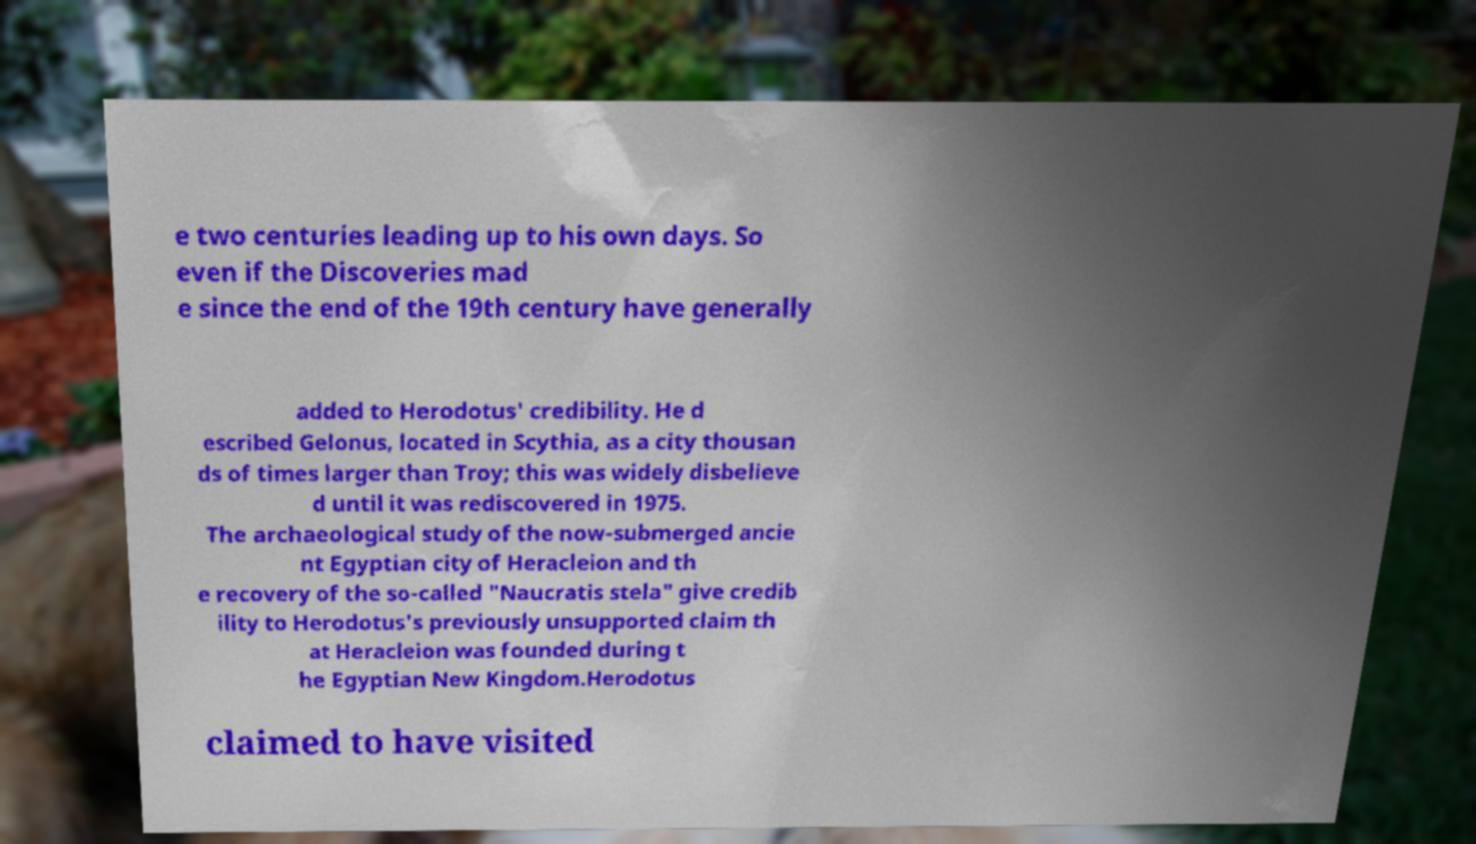Can you read and provide the text displayed in the image?This photo seems to have some interesting text. Can you extract and type it out for me? e two centuries leading up to his own days. So even if the Discoveries mad e since the end of the 19th century have generally added to Herodotus' credibility. He d escribed Gelonus, located in Scythia, as a city thousan ds of times larger than Troy; this was widely disbelieve d until it was rediscovered in 1975. The archaeological study of the now-submerged ancie nt Egyptian city of Heracleion and th e recovery of the so-called "Naucratis stela" give credib ility to Herodotus's previously unsupported claim th at Heracleion was founded during t he Egyptian New Kingdom.Herodotus claimed to have visited 